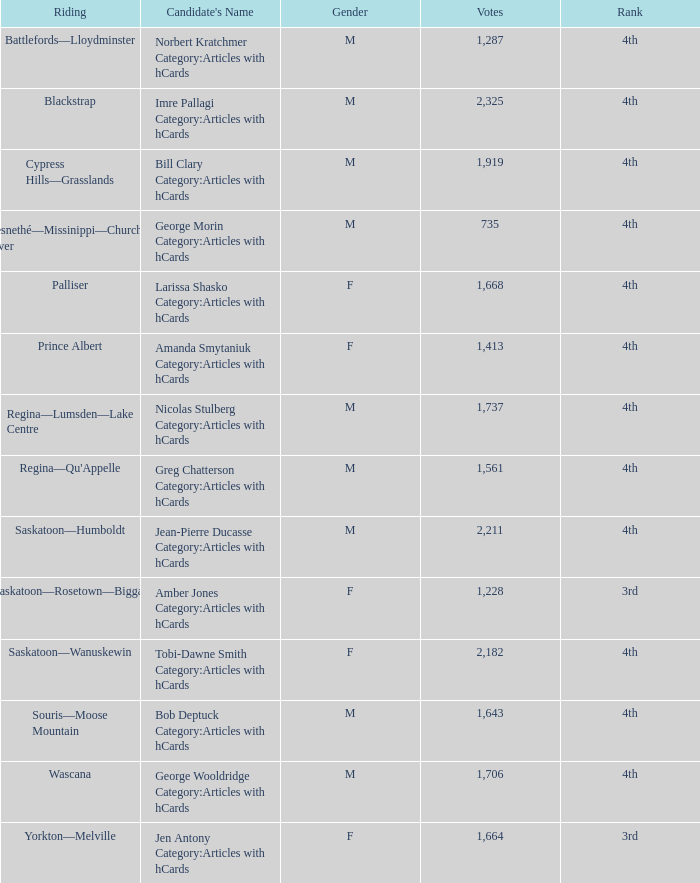What is the standing of the candidate who has received more than 2,211 votes? 4th. 